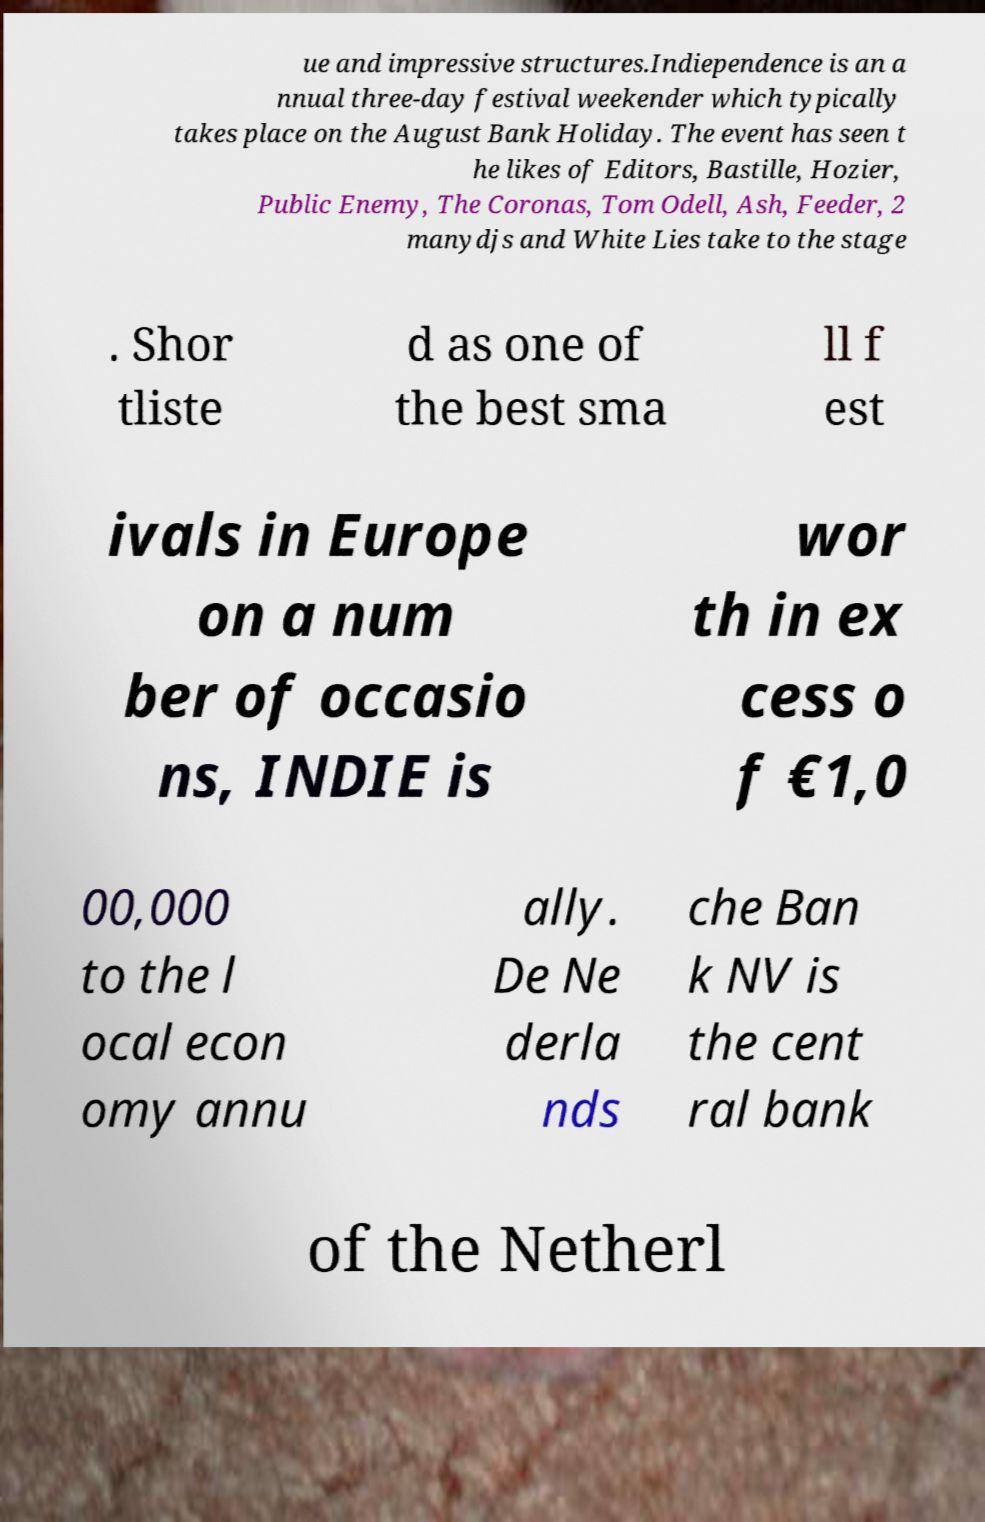Can you accurately transcribe the text from the provided image for me? ue and impressive structures.Indiependence is an a nnual three-day festival weekender which typically takes place on the August Bank Holiday. The event has seen t he likes of Editors, Bastille, Hozier, Public Enemy, The Coronas, Tom Odell, Ash, Feeder, 2 manydjs and White Lies take to the stage . Shor tliste d as one of the best sma ll f est ivals in Europe on a num ber of occasio ns, INDIE is wor th in ex cess o f €1,0 00,000 to the l ocal econ omy annu ally. De Ne derla nds che Ban k NV is the cent ral bank of the Netherl 